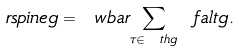Convert formula to latex. <formula><loc_0><loc_0><loc_500><loc_500>\ r s p i n e g = \ w b a r { \sum _ { \tau \in \ t h g } \ f a l t g } .</formula> 